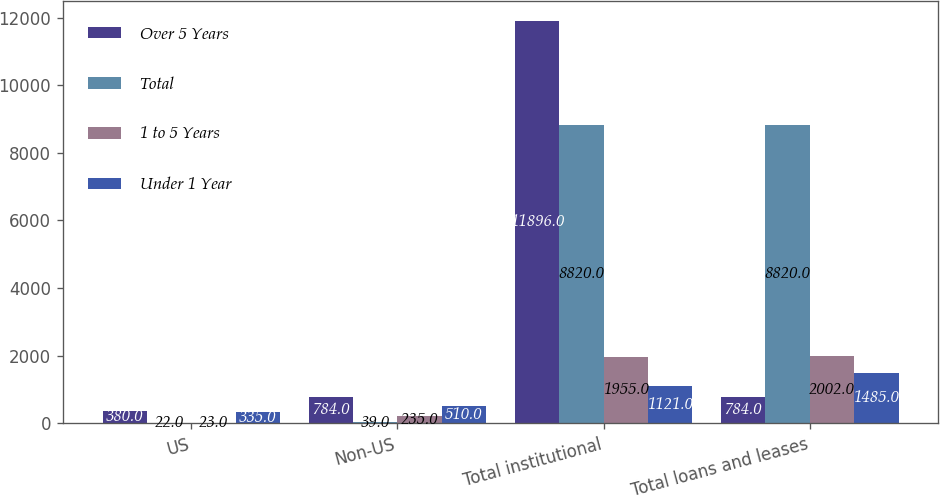Convert chart. <chart><loc_0><loc_0><loc_500><loc_500><stacked_bar_chart><ecel><fcel>US<fcel>Non-US<fcel>Total institutional<fcel>Total loans and leases<nl><fcel>Over 5 Years<fcel>380<fcel>784<fcel>11896<fcel>784<nl><fcel>Total<fcel>22<fcel>39<fcel>8820<fcel>8820<nl><fcel>1 to 5 Years<fcel>23<fcel>235<fcel>1955<fcel>2002<nl><fcel>Under 1 Year<fcel>335<fcel>510<fcel>1121<fcel>1485<nl></chart> 